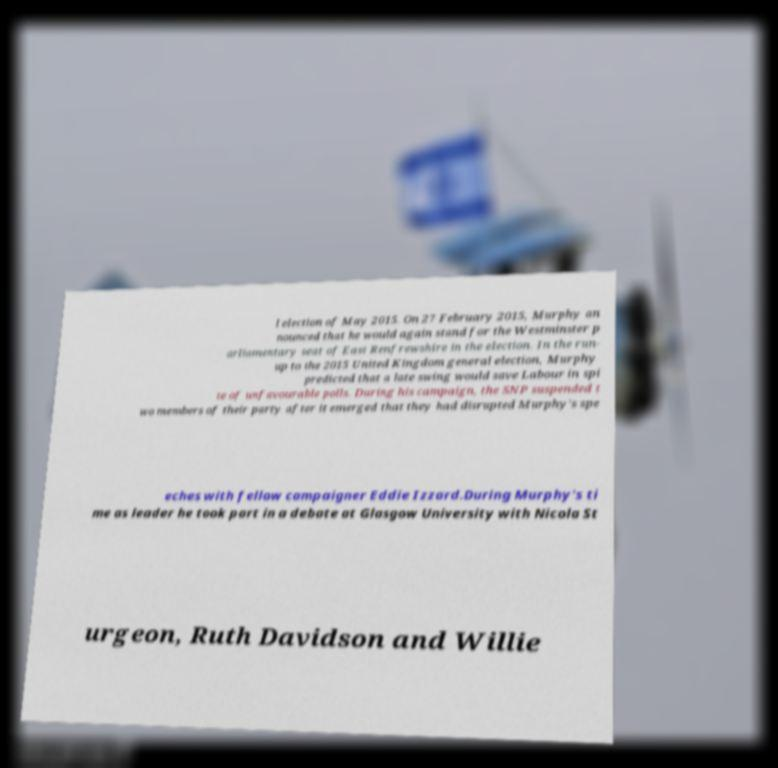There's text embedded in this image that I need extracted. Can you transcribe it verbatim? l election of May 2015. On 27 February 2015, Murphy an nounced that he would again stand for the Westminster p arliamentary seat of East Renfrewshire in the election. In the run- up to the 2015 United Kingdom general election, Murphy predicted that a late swing would save Labour in spi te of unfavourable polls. During his campaign, the SNP suspended t wo members of their party after it emerged that they had disrupted Murphy's spe eches with fellow campaigner Eddie Izzard.During Murphy's ti me as leader he took part in a debate at Glasgow University with Nicola St urgeon, Ruth Davidson and Willie 